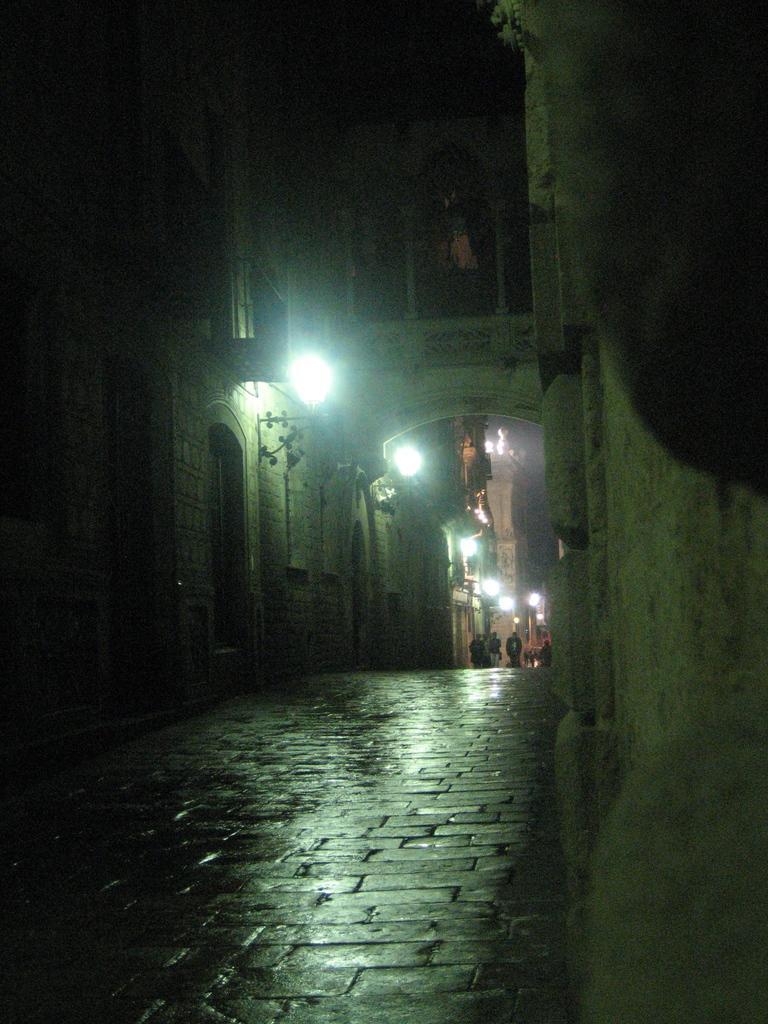Can you describe this image briefly? In this image I can see the road. To the side of the road there are buildings and I can see the lights to it. In the background I can see the group of people. 